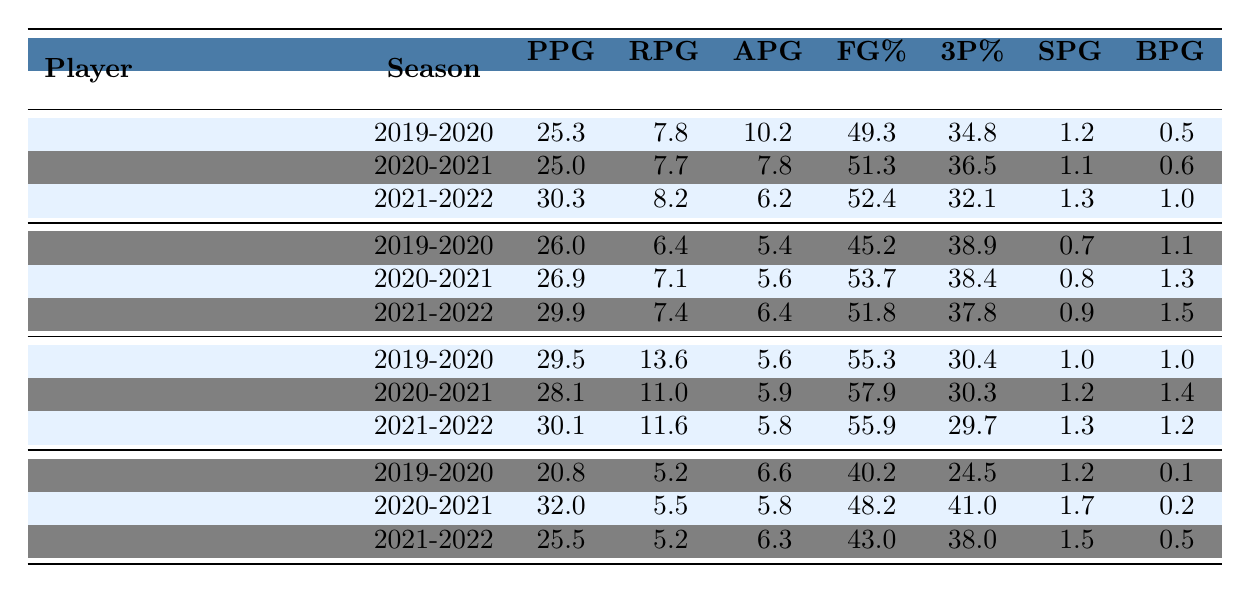What was LeBron James' highest points per game in the data provided? In the table, LeBron James' points per game for each season are 25.3, 25.0, and 30.3. The highest of these values is 30.3 from the 2021-2022 season.
Answer: 30.3 What was Kevin Durant's average rebounds per game across the three seasons? Kevin Durant's rebounds per game are 6.4, 7.1, and 7.4. Adding these values gives 6.4 + 7.1 + 7.4 = 21.0. There are three seasons, so dividing the sum by three gives 21.0 / 3 = 7.0.
Answer: 7.0 Did Stephen Curry have a season with a field goal percentage greater than 50%? Reviewing Stephen Curry's field goal percentages, we see they are 40.2%, 48.2%, and 43.0%, all of which are below 50%. Therefore, no season exceeds this threshold.
Answer: No Which player had the highest assists per game in the 2020-2021 season? In the 2020-2021 season, the assists per game are as follows: LeBron James 7.8, Kevin Durant 5.6, Giannis Antetokounmpo 5.9, and Stephen Curry 5.8. Comparing these, LeBron James had the highest at 7.8 assists per game.
Answer: LeBron James What is the total number of blocks per game by Giannis Antetokounmpo across all seasons? Giannis' blocks per game are 1.0, 1.4, and 1.2 for the seasons respectively. Adding these gives 1.0 + 1.4 + 1.2 = 3.6, which is the total blocks per game across the seasons.
Answer: 3.6 Which player improved their three-point shooting percentage the most from 2019-2020 to 2020-2021? Evaluating the three-point shooting percentages: for LeBron James, it improved from 34.8% to 36.5% (2.0% increase); for Kevin Durant, it improved from 38.9% to 38.4% (0.5% decrease); for Giannis, it decreased from 30.4% to 30.3% (0.1% decrease); for Stephen Curry, it improved from 24.5% to 41.0% (16.5% increase). The largest improvement was Stephen Curry's 16.5%.
Answer: Stephen Curry What was the average points per game for all players combined in the 2021-2022 season? Points per game for 2021-2022 are: LeBron James 30.3, Kevin Durant 29.9, Giannis Antetokounmpo 30.1, and Stephen Curry 25.5. Adding these gives 30.3 + 29.9 + 30.1 + 25.5 = 115.8. Dividing by 4 players gives 115.8 / 4 = 28.95.
Answer: 28.95 Did any player average over 30 points per game in the 2021-2022 season? Checking each player's points per game for 2021-2022, we find LeBron James 30.3, Kevin Durant 29.9, Giannis Antetokounmpo 30.1, and Stephen Curry 25.5. Only LeBron James exceeded 30 points per game, thus he is the only one.
Answer: Yes What was the difference in rebounds per game between Kevin Durant in 2019-2020 and LeBron James in 2020-2021? Kevin Durant's rebounds in 2019-2020 were 6.4, while LeBron James' rebounds in 2020-2021 were 7.7. To find the difference, subtract Durant's rebounds from James' rebounds: 7.7 - 6.4 = 1.3.
Answer: 1.3 Which season had the lowest average field goal percentage among the players? Checking each player's field goal percentages per season, for 2019-2020, the average is (49.3 + 45.2 + 55.3 + 40.2) / 4 = 47.5%. For 2020-2021, it's (51.3 + 53.7 + 57.9 + 48.2) / 4 = 52.775%. For 2021-2022, it's (52.4 + 51.8 + 55.9 + 43.0) / 4 = 50.775%. The lowest average field goal percentage is from 2019-2020 at 47.5%.
Answer: 2019-2020 